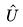Convert formula to latex. <formula><loc_0><loc_0><loc_500><loc_500>\hat { U }</formula> 